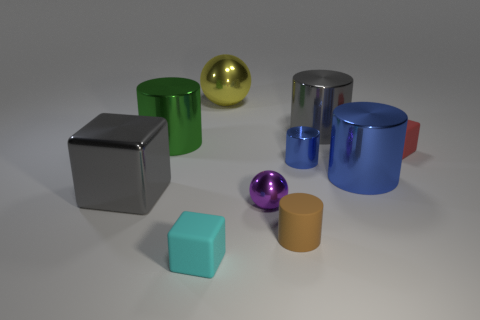Subtract all small metal cylinders. How many cylinders are left? 4 Subtract all red blocks. Subtract all red cylinders. How many blocks are left? 2 Subtract all spheres. How many objects are left? 8 Subtract 1 green cylinders. How many objects are left? 9 Subtract all tiny cylinders. Subtract all small rubber cubes. How many objects are left? 6 Add 4 cyan blocks. How many cyan blocks are left? 5 Add 10 large brown rubber spheres. How many large brown rubber spheres exist? 10 